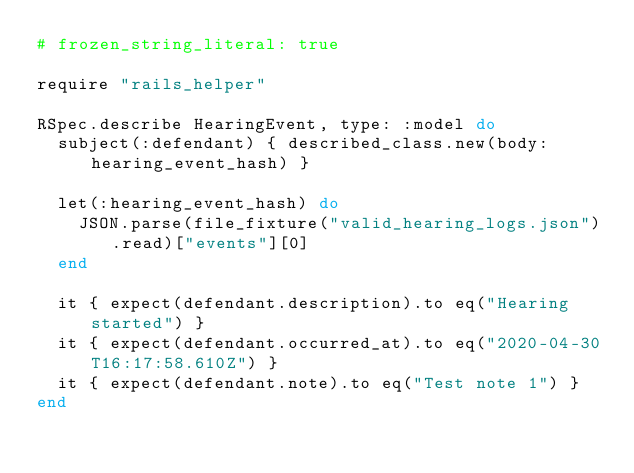<code> <loc_0><loc_0><loc_500><loc_500><_Ruby_># frozen_string_literal: true

require "rails_helper"

RSpec.describe HearingEvent, type: :model do
  subject(:defendant) { described_class.new(body: hearing_event_hash) }

  let(:hearing_event_hash) do
    JSON.parse(file_fixture("valid_hearing_logs.json").read)["events"][0]
  end

  it { expect(defendant.description).to eq("Hearing started") }
  it { expect(defendant.occurred_at).to eq("2020-04-30T16:17:58.610Z") }
  it { expect(defendant.note).to eq("Test note 1") }
end
</code> 